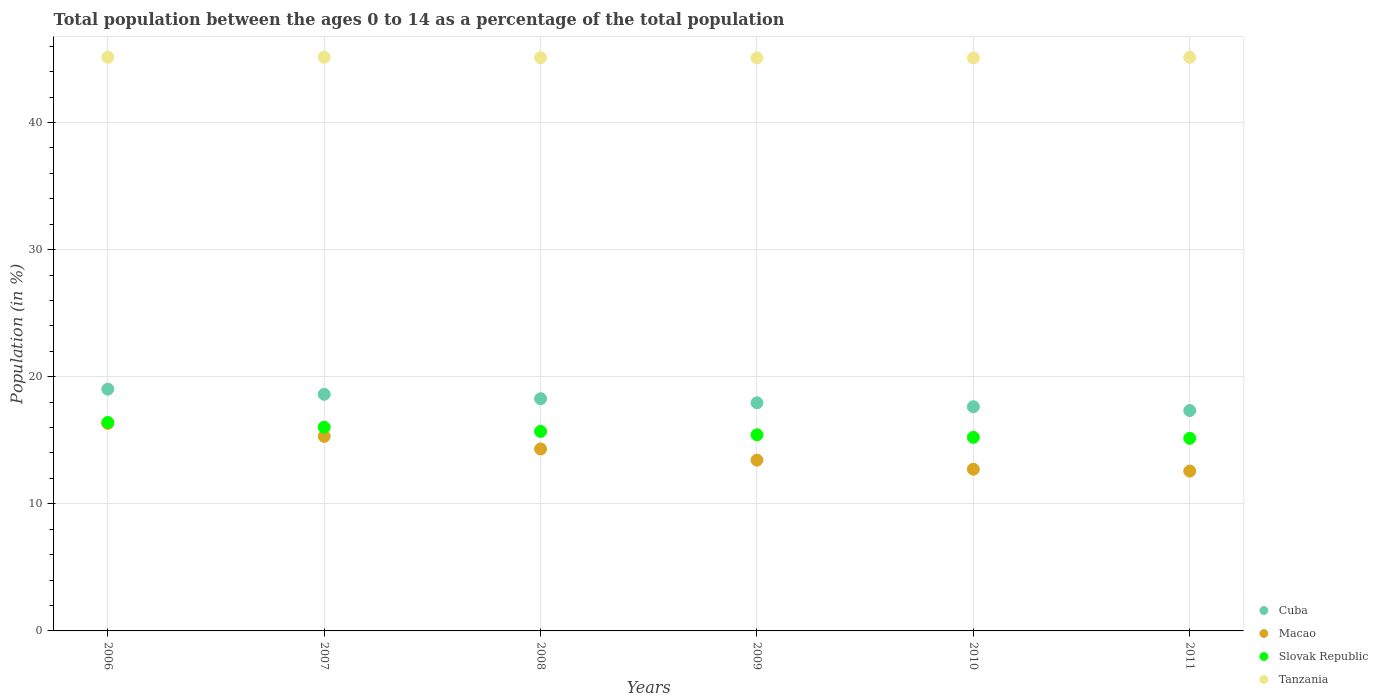How many different coloured dotlines are there?
Your answer should be very brief. 4. What is the percentage of the population ages 0 to 14 in Macao in 2007?
Your response must be concise. 15.31. Across all years, what is the maximum percentage of the population ages 0 to 14 in Macao?
Make the answer very short. 16.33. Across all years, what is the minimum percentage of the population ages 0 to 14 in Slovak Republic?
Your response must be concise. 15.15. In which year was the percentage of the population ages 0 to 14 in Macao maximum?
Your response must be concise. 2006. In which year was the percentage of the population ages 0 to 14 in Slovak Republic minimum?
Provide a short and direct response. 2011. What is the total percentage of the population ages 0 to 14 in Macao in the graph?
Provide a succinct answer. 84.68. What is the difference between the percentage of the population ages 0 to 14 in Tanzania in 2006 and that in 2009?
Provide a succinct answer. 0.05. What is the difference between the percentage of the population ages 0 to 14 in Macao in 2011 and the percentage of the population ages 0 to 14 in Tanzania in 2007?
Your answer should be very brief. -32.56. What is the average percentage of the population ages 0 to 14 in Macao per year?
Provide a short and direct response. 14.11. In the year 2008, what is the difference between the percentage of the population ages 0 to 14 in Cuba and percentage of the population ages 0 to 14 in Slovak Republic?
Offer a terse response. 2.57. What is the ratio of the percentage of the population ages 0 to 14 in Slovak Republic in 2009 to that in 2011?
Your answer should be very brief. 1.02. Is the percentage of the population ages 0 to 14 in Macao in 2006 less than that in 2010?
Your answer should be very brief. No. Is the difference between the percentage of the population ages 0 to 14 in Cuba in 2010 and 2011 greater than the difference between the percentage of the population ages 0 to 14 in Slovak Republic in 2010 and 2011?
Your answer should be compact. Yes. What is the difference between the highest and the second highest percentage of the population ages 0 to 14 in Tanzania?
Make the answer very short. 0. What is the difference between the highest and the lowest percentage of the population ages 0 to 14 in Cuba?
Provide a short and direct response. 1.68. Is the sum of the percentage of the population ages 0 to 14 in Macao in 2006 and 2008 greater than the maximum percentage of the population ages 0 to 14 in Cuba across all years?
Your answer should be very brief. Yes. Is it the case that in every year, the sum of the percentage of the population ages 0 to 14 in Cuba and percentage of the population ages 0 to 14 in Tanzania  is greater than the sum of percentage of the population ages 0 to 14 in Slovak Republic and percentage of the population ages 0 to 14 in Macao?
Provide a succinct answer. Yes. Does the percentage of the population ages 0 to 14 in Slovak Republic monotonically increase over the years?
Keep it short and to the point. No. How many years are there in the graph?
Offer a very short reply. 6. What is the difference between two consecutive major ticks on the Y-axis?
Make the answer very short. 10. Does the graph contain any zero values?
Your response must be concise. No. Does the graph contain grids?
Offer a terse response. Yes. How many legend labels are there?
Keep it short and to the point. 4. What is the title of the graph?
Give a very brief answer. Total population between the ages 0 to 14 as a percentage of the total population. What is the label or title of the Y-axis?
Your response must be concise. Population (in %). What is the Population (in %) of Cuba in 2006?
Ensure brevity in your answer.  19.02. What is the Population (in %) in Macao in 2006?
Provide a succinct answer. 16.33. What is the Population (in %) of Slovak Republic in 2006?
Make the answer very short. 16.4. What is the Population (in %) of Tanzania in 2006?
Provide a short and direct response. 45.13. What is the Population (in %) in Cuba in 2007?
Keep it short and to the point. 18.61. What is the Population (in %) in Macao in 2007?
Offer a terse response. 15.31. What is the Population (in %) of Slovak Republic in 2007?
Your answer should be very brief. 16.02. What is the Population (in %) in Tanzania in 2007?
Keep it short and to the point. 45.13. What is the Population (in %) in Cuba in 2008?
Keep it short and to the point. 18.27. What is the Population (in %) of Macao in 2008?
Your answer should be very brief. 14.32. What is the Population (in %) in Slovak Republic in 2008?
Your response must be concise. 15.7. What is the Population (in %) in Tanzania in 2008?
Give a very brief answer. 45.1. What is the Population (in %) in Cuba in 2009?
Provide a succinct answer. 17.95. What is the Population (in %) in Macao in 2009?
Your response must be concise. 13.43. What is the Population (in %) of Slovak Republic in 2009?
Give a very brief answer. 15.43. What is the Population (in %) in Tanzania in 2009?
Ensure brevity in your answer.  45.08. What is the Population (in %) in Cuba in 2010?
Provide a succinct answer. 17.64. What is the Population (in %) of Macao in 2010?
Your answer should be compact. 12.72. What is the Population (in %) in Slovak Republic in 2010?
Provide a succinct answer. 15.23. What is the Population (in %) of Tanzania in 2010?
Your answer should be compact. 45.08. What is the Population (in %) of Cuba in 2011?
Offer a very short reply. 17.34. What is the Population (in %) in Macao in 2011?
Provide a short and direct response. 12.57. What is the Population (in %) in Slovak Republic in 2011?
Offer a terse response. 15.15. What is the Population (in %) in Tanzania in 2011?
Your response must be concise. 45.12. Across all years, what is the maximum Population (in %) of Cuba?
Offer a terse response. 19.02. Across all years, what is the maximum Population (in %) of Macao?
Provide a succinct answer. 16.33. Across all years, what is the maximum Population (in %) in Slovak Republic?
Offer a terse response. 16.4. Across all years, what is the maximum Population (in %) in Tanzania?
Your response must be concise. 45.13. Across all years, what is the minimum Population (in %) of Cuba?
Make the answer very short. 17.34. Across all years, what is the minimum Population (in %) of Macao?
Your answer should be compact. 12.57. Across all years, what is the minimum Population (in %) in Slovak Republic?
Your answer should be very brief. 15.15. Across all years, what is the minimum Population (in %) in Tanzania?
Provide a short and direct response. 45.08. What is the total Population (in %) in Cuba in the graph?
Keep it short and to the point. 108.83. What is the total Population (in %) in Macao in the graph?
Ensure brevity in your answer.  84.68. What is the total Population (in %) of Slovak Republic in the graph?
Your response must be concise. 93.93. What is the total Population (in %) in Tanzania in the graph?
Your response must be concise. 270.64. What is the difference between the Population (in %) of Cuba in 2006 and that in 2007?
Your answer should be very brief. 0.41. What is the difference between the Population (in %) of Macao in 2006 and that in 2007?
Your response must be concise. 1.02. What is the difference between the Population (in %) of Slovak Republic in 2006 and that in 2007?
Your answer should be very brief. 0.37. What is the difference between the Population (in %) of Cuba in 2006 and that in 2008?
Provide a succinct answer. 0.75. What is the difference between the Population (in %) in Macao in 2006 and that in 2008?
Offer a very short reply. 2.01. What is the difference between the Population (in %) in Slovak Republic in 2006 and that in 2008?
Your answer should be compact. 0.7. What is the difference between the Population (in %) of Tanzania in 2006 and that in 2008?
Make the answer very short. 0.03. What is the difference between the Population (in %) in Cuba in 2006 and that in 2009?
Keep it short and to the point. 1.07. What is the difference between the Population (in %) in Macao in 2006 and that in 2009?
Provide a succinct answer. 2.89. What is the difference between the Population (in %) of Slovak Republic in 2006 and that in 2009?
Provide a short and direct response. 0.97. What is the difference between the Population (in %) in Tanzania in 2006 and that in 2009?
Make the answer very short. 0.05. What is the difference between the Population (in %) in Cuba in 2006 and that in 2010?
Your answer should be compact. 1.38. What is the difference between the Population (in %) in Macao in 2006 and that in 2010?
Your answer should be compact. 3.6. What is the difference between the Population (in %) in Slovak Republic in 2006 and that in 2010?
Your response must be concise. 1.17. What is the difference between the Population (in %) of Tanzania in 2006 and that in 2010?
Keep it short and to the point. 0.05. What is the difference between the Population (in %) of Cuba in 2006 and that in 2011?
Ensure brevity in your answer.  1.68. What is the difference between the Population (in %) of Macao in 2006 and that in 2011?
Your answer should be very brief. 3.75. What is the difference between the Population (in %) of Slovak Republic in 2006 and that in 2011?
Offer a very short reply. 1.25. What is the difference between the Population (in %) in Tanzania in 2006 and that in 2011?
Give a very brief answer. 0.01. What is the difference between the Population (in %) in Cuba in 2007 and that in 2008?
Make the answer very short. 0.35. What is the difference between the Population (in %) of Macao in 2007 and that in 2008?
Your response must be concise. 0.99. What is the difference between the Population (in %) in Slovak Republic in 2007 and that in 2008?
Your answer should be compact. 0.33. What is the difference between the Population (in %) in Tanzania in 2007 and that in 2008?
Provide a short and direct response. 0.03. What is the difference between the Population (in %) of Cuba in 2007 and that in 2009?
Offer a very short reply. 0.67. What is the difference between the Population (in %) in Macao in 2007 and that in 2009?
Provide a succinct answer. 1.87. What is the difference between the Population (in %) of Slovak Republic in 2007 and that in 2009?
Provide a short and direct response. 0.59. What is the difference between the Population (in %) in Tanzania in 2007 and that in 2009?
Your answer should be very brief. 0.05. What is the difference between the Population (in %) of Cuba in 2007 and that in 2010?
Your answer should be compact. 0.98. What is the difference between the Population (in %) of Macao in 2007 and that in 2010?
Provide a short and direct response. 2.58. What is the difference between the Population (in %) in Slovak Republic in 2007 and that in 2010?
Offer a terse response. 0.79. What is the difference between the Population (in %) in Tanzania in 2007 and that in 2010?
Give a very brief answer. 0.05. What is the difference between the Population (in %) of Cuba in 2007 and that in 2011?
Offer a terse response. 1.28. What is the difference between the Population (in %) of Macao in 2007 and that in 2011?
Keep it short and to the point. 2.73. What is the difference between the Population (in %) of Slovak Republic in 2007 and that in 2011?
Offer a terse response. 0.87. What is the difference between the Population (in %) in Tanzania in 2007 and that in 2011?
Ensure brevity in your answer.  0.01. What is the difference between the Population (in %) in Cuba in 2008 and that in 2009?
Provide a short and direct response. 0.32. What is the difference between the Population (in %) in Macao in 2008 and that in 2009?
Provide a succinct answer. 0.88. What is the difference between the Population (in %) in Slovak Republic in 2008 and that in 2009?
Ensure brevity in your answer.  0.27. What is the difference between the Population (in %) of Tanzania in 2008 and that in 2009?
Offer a very short reply. 0.02. What is the difference between the Population (in %) in Cuba in 2008 and that in 2010?
Your response must be concise. 0.63. What is the difference between the Population (in %) in Macao in 2008 and that in 2010?
Make the answer very short. 1.59. What is the difference between the Population (in %) of Slovak Republic in 2008 and that in 2010?
Keep it short and to the point. 0.47. What is the difference between the Population (in %) of Tanzania in 2008 and that in 2010?
Your response must be concise. 0.02. What is the difference between the Population (in %) of Cuba in 2008 and that in 2011?
Provide a short and direct response. 0.93. What is the difference between the Population (in %) in Macao in 2008 and that in 2011?
Make the answer very short. 1.74. What is the difference between the Population (in %) in Slovak Republic in 2008 and that in 2011?
Make the answer very short. 0.55. What is the difference between the Population (in %) in Tanzania in 2008 and that in 2011?
Your answer should be very brief. -0.02. What is the difference between the Population (in %) of Cuba in 2009 and that in 2010?
Offer a very short reply. 0.31. What is the difference between the Population (in %) in Macao in 2009 and that in 2010?
Give a very brief answer. 0.71. What is the difference between the Population (in %) in Slovak Republic in 2009 and that in 2010?
Your answer should be very brief. 0.2. What is the difference between the Population (in %) of Tanzania in 2009 and that in 2010?
Make the answer very short. -0. What is the difference between the Population (in %) in Cuba in 2009 and that in 2011?
Give a very brief answer. 0.61. What is the difference between the Population (in %) in Macao in 2009 and that in 2011?
Keep it short and to the point. 0.86. What is the difference between the Population (in %) in Slovak Republic in 2009 and that in 2011?
Offer a terse response. 0.28. What is the difference between the Population (in %) of Tanzania in 2009 and that in 2011?
Ensure brevity in your answer.  -0.04. What is the difference between the Population (in %) of Cuba in 2010 and that in 2011?
Your answer should be compact. 0.3. What is the difference between the Population (in %) in Macao in 2010 and that in 2011?
Offer a very short reply. 0.15. What is the difference between the Population (in %) of Slovak Republic in 2010 and that in 2011?
Your answer should be compact. 0.08. What is the difference between the Population (in %) of Tanzania in 2010 and that in 2011?
Your answer should be very brief. -0.04. What is the difference between the Population (in %) in Cuba in 2006 and the Population (in %) in Macao in 2007?
Ensure brevity in your answer.  3.71. What is the difference between the Population (in %) in Cuba in 2006 and the Population (in %) in Slovak Republic in 2007?
Give a very brief answer. 3. What is the difference between the Population (in %) of Cuba in 2006 and the Population (in %) of Tanzania in 2007?
Give a very brief answer. -26.11. What is the difference between the Population (in %) of Macao in 2006 and the Population (in %) of Slovak Republic in 2007?
Your response must be concise. 0.3. What is the difference between the Population (in %) in Macao in 2006 and the Population (in %) in Tanzania in 2007?
Your response must be concise. -28.81. What is the difference between the Population (in %) of Slovak Republic in 2006 and the Population (in %) of Tanzania in 2007?
Make the answer very short. -28.73. What is the difference between the Population (in %) of Cuba in 2006 and the Population (in %) of Macao in 2008?
Make the answer very short. 4.71. What is the difference between the Population (in %) in Cuba in 2006 and the Population (in %) in Slovak Republic in 2008?
Provide a succinct answer. 3.32. What is the difference between the Population (in %) of Cuba in 2006 and the Population (in %) of Tanzania in 2008?
Your response must be concise. -26.08. What is the difference between the Population (in %) in Macao in 2006 and the Population (in %) in Slovak Republic in 2008?
Make the answer very short. 0.63. What is the difference between the Population (in %) in Macao in 2006 and the Population (in %) in Tanzania in 2008?
Provide a short and direct response. -28.77. What is the difference between the Population (in %) of Slovak Republic in 2006 and the Population (in %) of Tanzania in 2008?
Give a very brief answer. -28.7. What is the difference between the Population (in %) of Cuba in 2006 and the Population (in %) of Macao in 2009?
Your answer should be very brief. 5.59. What is the difference between the Population (in %) in Cuba in 2006 and the Population (in %) in Slovak Republic in 2009?
Give a very brief answer. 3.59. What is the difference between the Population (in %) of Cuba in 2006 and the Population (in %) of Tanzania in 2009?
Give a very brief answer. -26.06. What is the difference between the Population (in %) in Macao in 2006 and the Population (in %) in Slovak Republic in 2009?
Provide a short and direct response. 0.89. What is the difference between the Population (in %) in Macao in 2006 and the Population (in %) in Tanzania in 2009?
Provide a short and direct response. -28.75. What is the difference between the Population (in %) of Slovak Republic in 2006 and the Population (in %) of Tanzania in 2009?
Give a very brief answer. -28.68. What is the difference between the Population (in %) of Cuba in 2006 and the Population (in %) of Macao in 2010?
Keep it short and to the point. 6.3. What is the difference between the Population (in %) in Cuba in 2006 and the Population (in %) in Slovak Republic in 2010?
Your answer should be compact. 3.79. What is the difference between the Population (in %) of Cuba in 2006 and the Population (in %) of Tanzania in 2010?
Give a very brief answer. -26.06. What is the difference between the Population (in %) of Macao in 2006 and the Population (in %) of Slovak Republic in 2010?
Your answer should be very brief. 1.09. What is the difference between the Population (in %) of Macao in 2006 and the Population (in %) of Tanzania in 2010?
Offer a terse response. -28.76. What is the difference between the Population (in %) of Slovak Republic in 2006 and the Population (in %) of Tanzania in 2010?
Provide a short and direct response. -28.68. What is the difference between the Population (in %) in Cuba in 2006 and the Population (in %) in Macao in 2011?
Your answer should be very brief. 6.45. What is the difference between the Population (in %) in Cuba in 2006 and the Population (in %) in Slovak Republic in 2011?
Your answer should be very brief. 3.87. What is the difference between the Population (in %) in Cuba in 2006 and the Population (in %) in Tanzania in 2011?
Ensure brevity in your answer.  -26.1. What is the difference between the Population (in %) of Macao in 2006 and the Population (in %) of Slovak Republic in 2011?
Your answer should be very brief. 1.17. What is the difference between the Population (in %) in Macao in 2006 and the Population (in %) in Tanzania in 2011?
Give a very brief answer. -28.79. What is the difference between the Population (in %) of Slovak Republic in 2006 and the Population (in %) of Tanzania in 2011?
Keep it short and to the point. -28.72. What is the difference between the Population (in %) in Cuba in 2007 and the Population (in %) in Macao in 2008?
Your answer should be compact. 4.3. What is the difference between the Population (in %) of Cuba in 2007 and the Population (in %) of Slovak Republic in 2008?
Offer a very short reply. 2.92. What is the difference between the Population (in %) of Cuba in 2007 and the Population (in %) of Tanzania in 2008?
Offer a very short reply. -26.48. What is the difference between the Population (in %) in Macao in 2007 and the Population (in %) in Slovak Republic in 2008?
Make the answer very short. -0.39. What is the difference between the Population (in %) of Macao in 2007 and the Population (in %) of Tanzania in 2008?
Ensure brevity in your answer.  -29.79. What is the difference between the Population (in %) in Slovak Republic in 2007 and the Population (in %) in Tanzania in 2008?
Give a very brief answer. -29.07. What is the difference between the Population (in %) of Cuba in 2007 and the Population (in %) of Macao in 2009?
Provide a succinct answer. 5.18. What is the difference between the Population (in %) of Cuba in 2007 and the Population (in %) of Slovak Republic in 2009?
Your response must be concise. 3.18. What is the difference between the Population (in %) of Cuba in 2007 and the Population (in %) of Tanzania in 2009?
Make the answer very short. -26.46. What is the difference between the Population (in %) in Macao in 2007 and the Population (in %) in Slovak Republic in 2009?
Ensure brevity in your answer.  -0.13. What is the difference between the Population (in %) in Macao in 2007 and the Population (in %) in Tanzania in 2009?
Ensure brevity in your answer.  -29.77. What is the difference between the Population (in %) in Slovak Republic in 2007 and the Population (in %) in Tanzania in 2009?
Your response must be concise. -29.05. What is the difference between the Population (in %) of Cuba in 2007 and the Population (in %) of Macao in 2010?
Offer a terse response. 5.89. What is the difference between the Population (in %) of Cuba in 2007 and the Population (in %) of Slovak Republic in 2010?
Your response must be concise. 3.38. What is the difference between the Population (in %) in Cuba in 2007 and the Population (in %) in Tanzania in 2010?
Provide a short and direct response. -26.47. What is the difference between the Population (in %) of Macao in 2007 and the Population (in %) of Slovak Republic in 2010?
Keep it short and to the point. 0.08. What is the difference between the Population (in %) of Macao in 2007 and the Population (in %) of Tanzania in 2010?
Your answer should be compact. -29.77. What is the difference between the Population (in %) of Slovak Republic in 2007 and the Population (in %) of Tanzania in 2010?
Give a very brief answer. -29.06. What is the difference between the Population (in %) in Cuba in 2007 and the Population (in %) in Macao in 2011?
Your answer should be very brief. 6.04. What is the difference between the Population (in %) in Cuba in 2007 and the Population (in %) in Slovak Republic in 2011?
Make the answer very short. 3.46. What is the difference between the Population (in %) in Cuba in 2007 and the Population (in %) in Tanzania in 2011?
Offer a terse response. -26.5. What is the difference between the Population (in %) in Macao in 2007 and the Population (in %) in Slovak Republic in 2011?
Make the answer very short. 0.15. What is the difference between the Population (in %) of Macao in 2007 and the Population (in %) of Tanzania in 2011?
Keep it short and to the point. -29.81. What is the difference between the Population (in %) in Slovak Republic in 2007 and the Population (in %) in Tanzania in 2011?
Your response must be concise. -29.09. What is the difference between the Population (in %) in Cuba in 2008 and the Population (in %) in Macao in 2009?
Provide a short and direct response. 4.84. What is the difference between the Population (in %) of Cuba in 2008 and the Population (in %) of Slovak Republic in 2009?
Provide a succinct answer. 2.84. What is the difference between the Population (in %) of Cuba in 2008 and the Population (in %) of Tanzania in 2009?
Offer a terse response. -26.81. What is the difference between the Population (in %) of Macao in 2008 and the Population (in %) of Slovak Republic in 2009?
Your response must be concise. -1.12. What is the difference between the Population (in %) in Macao in 2008 and the Population (in %) in Tanzania in 2009?
Your answer should be very brief. -30.76. What is the difference between the Population (in %) of Slovak Republic in 2008 and the Population (in %) of Tanzania in 2009?
Ensure brevity in your answer.  -29.38. What is the difference between the Population (in %) in Cuba in 2008 and the Population (in %) in Macao in 2010?
Ensure brevity in your answer.  5.55. What is the difference between the Population (in %) in Cuba in 2008 and the Population (in %) in Slovak Republic in 2010?
Offer a terse response. 3.04. What is the difference between the Population (in %) in Cuba in 2008 and the Population (in %) in Tanzania in 2010?
Your answer should be very brief. -26.81. What is the difference between the Population (in %) of Macao in 2008 and the Population (in %) of Slovak Republic in 2010?
Your answer should be very brief. -0.92. What is the difference between the Population (in %) of Macao in 2008 and the Population (in %) of Tanzania in 2010?
Give a very brief answer. -30.76. What is the difference between the Population (in %) of Slovak Republic in 2008 and the Population (in %) of Tanzania in 2010?
Ensure brevity in your answer.  -29.38. What is the difference between the Population (in %) in Cuba in 2008 and the Population (in %) in Macao in 2011?
Your response must be concise. 5.69. What is the difference between the Population (in %) of Cuba in 2008 and the Population (in %) of Slovak Republic in 2011?
Offer a terse response. 3.12. What is the difference between the Population (in %) of Cuba in 2008 and the Population (in %) of Tanzania in 2011?
Your answer should be very brief. -26.85. What is the difference between the Population (in %) of Macao in 2008 and the Population (in %) of Slovak Republic in 2011?
Offer a terse response. -0.84. What is the difference between the Population (in %) in Macao in 2008 and the Population (in %) in Tanzania in 2011?
Provide a succinct answer. -30.8. What is the difference between the Population (in %) in Slovak Republic in 2008 and the Population (in %) in Tanzania in 2011?
Your response must be concise. -29.42. What is the difference between the Population (in %) in Cuba in 2009 and the Population (in %) in Macao in 2010?
Your answer should be compact. 5.23. What is the difference between the Population (in %) of Cuba in 2009 and the Population (in %) of Slovak Republic in 2010?
Ensure brevity in your answer.  2.72. What is the difference between the Population (in %) of Cuba in 2009 and the Population (in %) of Tanzania in 2010?
Provide a short and direct response. -27.13. What is the difference between the Population (in %) of Macao in 2009 and the Population (in %) of Slovak Republic in 2010?
Offer a very short reply. -1.8. What is the difference between the Population (in %) of Macao in 2009 and the Population (in %) of Tanzania in 2010?
Your answer should be very brief. -31.65. What is the difference between the Population (in %) in Slovak Republic in 2009 and the Population (in %) in Tanzania in 2010?
Provide a short and direct response. -29.65. What is the difference between the Population (in %) in Cuba in 2009 and the Population (in %) in Macao in 2011?
Offer a terse response. 5.37. What is the difference between the Population (in %) of Cuba in 2009 and the Population (in %) of Slovak Republic in 2011?
Keep it short and to the point. 2.8. What is the difference between the Population (in %) of Cuba in 2009 and the Population (in %) of Tanzania in 2011?
Your answer should be very brief. -27.17. What is the difference between the Population (in %) of Macao in 2009 and the Population (in %) of Slovak Republic in 2011?
Your response must be concise. -1.72. What is the difference between the Population (in %) of Macao in 2009 and the Population (in %) of Tanzania in 2011?
Provide a short and direct response. -31.69. What is the difference between the Population (in %) of Slovak Republic in 2009 and the Population (in %) of Tanzania in 2011?
Offer a terse response. -29.69. What is the difference between the Population (in %) in Cuba in 2010 and the Population (in %) in Macao in 2011?
Your answer should be very brief. 5.06. What is the difference between the Population (in %) of Cuba in 2010 and the Population (in %) of Slovak Republic in 2011?
Ensure brevity in your answer.  2.49. What is the difference between the Population (in %) in Cuba in 2010 and the Population (in %) in Tanzania in 2011?
Your answer should be very brief. -27.48. What is the difference between the Population (in %) in Macao in 2010 and the Population (in %) in Slovak Republic in 2011?
Provide a short and direct response. -2.43. What is the difference between the Population (in %) in Macao in 2010 and the Population (in %) in Tanzania in 2011?
Make the answer very short. -32.4. What is the difference between the Population (in %) of Slovak Republic in 2010 and the Population (in %) of Tanzania in 2011?
Your answer should be very brief. -29.89. What is the average Population (in %) in Cuba per year?
Give a very brief answer. 18.14. What is the average Population (in %) in Macao per year?
Your answer should be very brief. 14.11. What is the average Population (in %) in Slovak Republic per year?
Your answer should be compact. 15.66. What is the average Population (in %) of Tanzania per year?
Make the answer very short. 45.11. In the year 2006, what is the difference between the Population (in %) of Cuba and Population (in %) of Macao?
Ensure brevity in your answer.  2.7. In the year 2006, what is the difference between the Population (in %) of Cuba and Population (in %) of Slovak Republic?
Keep it short and to the point. 2.62. In the year 2006, what is the difference between the Population (in %) of Cuba and Population (in %) of Tanzania?
Ensure brevity in your answer.  -26.11. In the year 2006, what is the difference between the Population (in %) in Macao and Population (in %) in Slovak Republic?
Ensure brevity in your answer.  -0.07. In the year 2006, what is the difference between the Population (in %) in Macao and Population (in %) in Tanzania?
Offer a terse response. -28.81. In the year 2006, what is the difference between the Population (in %) of Slovak Republic and Population (in %) of Tanzania?
Provide a succinct answer. -28.73. In the year 2007, what is the difference between the Population (in %) of Cuba and Population (in %) of Macao?
Your answer should be very brief. 3.31. In the year 2007, what is the difference between the Population (in %) of Cuba and Population (in %) of Slovak Republic?
Your answer should be very brief. 2.59. In the year 2007, what is the difference between the Population (in %) of Cuba and Population (in %) of Tanzania?
Offer a terse response. -26.52. In the year 2007, what is the difference between the Population (in %) of Macao and Population (in %) of Slovak Republic?
Your response must be concise. -0.72. In the year 2007, what is the difference between the Population (in %) in Macao and Population (in %) in Tanzania?
Your answer should be very brief. -29.82. In the year 2007, what is the difference between the Population (in %) of Slovak Republic and Population (in %) of Tanzania?
Keep it short and to the point. -29.11. In the year 2008, what is the difference between the Population (in %) in Cuba and Population (in %) in Macao?
Ensure brevity in your answer.  3.95. In the year 2008, what is the difference between the Population (in %) of Cuba and Population (in %) of Slovak Republic?
Your response must be concise. 2.57. In the year 2008, what is the difference between the Population (in %) in Cuba and Population (in %) in Tanzania?
Make the answer very short. -26.83. In the year 2008, what is the difference between the Population (in %) in Macao and Population (in %) in Slovak Republic?
Your answer should be compact. -1.38. In the year 2008, what is the difference between the Population (in %) of Macao and Population (in %) of Tanzania?
Give a very brief answer. -30.78. In the year 2008, what is the difference between the Population (in %) of Slovak Republic and Population (in %) of Tanzania?
Provide a short and direct response. -29.4. In the year 2009, what is the difference between the Population (in %) of Cuba and Population (in %) of Macao?
Provide a short and direct response. 4.51. In the year 2009, what is the difference between the Population (in %) in Cuba and Population (in %) in Slovak Republic?
Your answer should be very brief. 2.52. In the year 2009, what is the difference between the Population (in %) of Cuba and Population (in %) of Tanzania?
Your answer should be very brief. -27.13. In the year 2009, what is the difference between the Population (in %) in Macao and Population (in %) in Slovak Republic?
Offer a very short reply. -2. In the year 2009, what is the difference between the Population (in %) of Macao and Population (in %) of Tanzania?
Offer a terse response. -31.64. In the year 2009, what is the difference between the Population (in %) of Slovak Republic and Population (in %) of Tanzania?
Your answer should be very brief. -29.64. In the year 2010, what is the difference between the Population (in %) in Cuba and Population (in %) in Macao?
Provide a short and direct response. 4.92. In the year 2010, what is the difference between the Population (in %) in Cuba and Population (in %) in Slovak Republic?
Your answer should be very brief. 2.41. In the year 2010, what is the difference between the Population (in %) of Cuba and Population (in %) of Tanzania?
Provide a succinct answer. -27.44. In the year 2010, what is the difference between the Population (in %) in Macao and Population (in %) in Slovak Republic?
Provide a succinct answer. -2.51. In the year 2010, what is the difference between the Population (in %) in Macao and Population (in %) in Tanzania?
Your response must be concise. -32.36. In the year 2010, what is the difference between the Population (in %) of Slovak Republic and Population (in %) of Tanzania?
Keep it short and to the point. -29.85. In the year 2011, what is the difference between the Population (in %) in Cuba and Population (in %) in Macao?
Offer a very short reply. 4.76. In the year 2011, what is the difference between the Population (in %) of Cuba and Population (in %) of Slovak Republic?
Your answer should be very brief. 2.19. In the year 2011, what is the difference between the Population (in %) in Cuba and Population (in %) in Tanzania?
Offer a very short reply. -27.78. In the year 2011, what is the difference between the Population (in %) in Macao and Population (in %) in Slovak Republic?
Provide a succinct answer. -2.58. In the year 2011, what is the difference between the Population (in %) in Macao and Population (in %) in Tanzania?
Your answer should be compact. -32.54. In the year 2011, what is the difference between the Population (in %) in Slovak Republic and Population (in %) in Tanzania?
Your answer should be very brief. -29.97. What is the ratio of the Population (in %) of Cuba in 2006 to that in 2007?
Your response must be concise. 1.02. What is the ratio of the Population (in %) in Macao in 2006 to that in 2007?
Ensure brevity in your answer.  1.07. What is the ratio of the Population (in %) in Slovak Republic in 2006 to that in 2007?
Offer a very short reply. 1.02. What is the ratio of the Population (in %) in Cuba in 2006 to that in 2008?
Provide a short and direct response. 1.04. What is the ratio of the Population (in %) of Macao in 2006 to that in 2008?
Make the answer very short. 1.14. What is the ratio of the Population (in %) in Slovak Republic in 2006 to that in 2008?
Keep it short and to the point. 1.04. What is the ratio of the Population (in %) in Tanzania in 2006 to that in 2008?
Ensure brevity in your answer.  1. What is the ratio of the Population (in %) of Cuba in 2006 to that in 2009?
Offer a terse response. 1.06. What is the ratio of the Population (in %) of Macao in 2006 to that in 2009?
Make the answer very short. 1.22. What is the ratio of the Population (in %) of Slovak Republic in 2006 to that in 2009?
Your answer should be compact. 1.06. What is the ratio of the Population (in %) in Tanzania in 2006 to that in 2009?
Give a very brief answer. 1. What is the ratio of the Population (in %) of Cuba in 2006 to that in 2010?
Your answer should be very brief. 1.08. What is the ratio of the Population (in %) of Macao in 2006 to that in 2010?
Your answer should be compact. 1.28. What is the ratio of the Population (in %) of Slovak Republic in 2006 to that in 2010?
Offer a terse response. 1.08. What is the ratio of the Population (in %) of Cuba in 2006 to that in 2011?
Offer a very short reply. 1.1. What is the ratio of the Population (in %) of Macao in 2006 to that in 2011?
Make the answer very short. 1.3. What is the ratio of the Population (in %) in Slovak Republic in 2006 to that in 2011?
Give a very brief answer. 1.08. What is the ratio of the Population (in %) in Tanzania in 2006 to that in 2011?
Ensure brevity in your answer.  1. What is the ratio of the Population (in %) in Macao in 2007 to that in 2008?
Make the answer very short. 1.07. What is the ratio of the Population (in %) of Slovak Republic in 2007 to that in 2008?
Offer a very short reply. 1.02. What is the ratio of the Population (in %) in Tanzania in 2007 to that in 2008?
Provide a succinct answer. 1. What is the ratio of the Population (in %) of Cuba in 2007 to that in 2009?
Provide a succinct answer. 1.04. What is the ratio of the Population (in %) of Macao in 2007 to that in 2009?
Offer a very short reply. 1.14. What is the ratio of the Population (in %) in Slovak Republic in 2007 to that in 2009?
Provide a succinct answer. 1.04. What is the ratio of the Population (in %) in Cuba in 2007 to that in 2010?
Ensure brevity in your answer.  1.06. What is the ratio of the Population (in %) in Macao in 2007 to that in 2010?
Make the answer very short. 1.2. What is the ratio of the Population (in %) in Slovak Republic in 2007 to that in 2010?
Your answer should be very brief. 1.05. What is the ratio of the Population (in %) in Cuba in 2007 to that in 2011?
Keep it short and to the point. 1.07. What is the ratio of the Population (in %) in Macao in 2007 to that in 2011?
Make the answer very short. 1.22. What is the ratio of the Population (in %) in Slovak Republic in 2007 to that in 2011?
Provide a short and direct response. 1.06. What is the ratio of the Population (in %) of Tanzania in 2007 to that in 2011?
Your answer should be compact. 1. What is the ratio of the Population (in %) in Cuba in 2008 to that in 2009?
Make the answer very short. 1.02. What is the ratio of the Population (in %) of Macao in 2008 to that in 2009?
Provide a succinct answer. 1.07. What is the ratio of the Population (in %) in Slovak Republic in 2008 to that in 2009?
Give a very brief answer. 1.02. What is the ratio of the Population (in %) in Tanzania in 2008 to that in 2009?
Ensure brevity in your answer.  1. What is the ratio of the Population (in %) of Cuba in 2008 to that in 2010?
Give a very brief answer. 1.04. What is the ratio of the Population (in %) in Macao in 2008 to that in 2010?
Offer a very short reply. 1.13. What is the ratio of the Population (in %) in Slovak Republic in 2008 to that in 2010?
Your answer should be very brief. 1.03. What is the ratio of the Population (in %) of Cuba in 2008 to that in 2011?
Keep it short and to the point. 1.05. What is the ratio of the Population (in %) of Macao in 2008 to that in 2011?
Provide a short and direct response. 1.14. What is the ratio of the Population (in %) in Slovak Republic in 2008 to that in 2011?
Make the answer very short. 1.04. What is the ratio of the Population (in %) in Tanzania in 2008 to that in 2011?
Ensure brevity in your answer.  1. What is the ratio of the Population (in %) in Cuba in 2009 to that in 2010?
Keep it short and to the point. 1.02. What is the ratio of the Population (in %) in Macao in 2009 to that in 2010?
Ensure brevity in your answer.  1.06. What is the ratio of the Population (in %) of Slovak Republic in 2009 to that in 2010?
Offer a very short reply. 1.01. What is the ratio of the Population (in %) in Cuba in 2009 to that in 2011?
Keep it short and to the point. 1.04. What is the ratio of the Population (in %) of Macao in 2009 to that in 2011?
Provide a short and direct response. 1.07. What is the ratio of the Population (in %) of Slovak Republic in 2009 to that in 2011?
Ensure brevity in your answer.  1.02. What is the ratio of the Population (in %) of Cuba in 2010 to that in 2011?
Offer a very short reply. 1.02. What is the ratio of the Population (in %) in Macao in 2010 to that in 2011?
Your response must be concise. 1.01. What is the difference between the highest and the second highest Population (in %) of Cuba?
Your answer should be compact. 0.41. What is the difference between the highest and the second highest Population (in %) in Macao?
Give a very brief answer. 1.02. What is the difference between the highest and the second highest Population (in %) of Slovak Republic?
Ensure brevity in your answer.  0.37. What is the difference between the highest and the lowest Population (in %) of Cuba?
Give a very brief answer. 1.68. What is the difference between the highest and the lowest Population (in %) of Macao?
Give a very brief answer. 3.75. What is the difference between the highest and the lowest Population (in %) in Slovak Republic?
Provide a succinct answer. 1.25. What is the difference between the highest and the lowest Population (in %) of Tanzania?
Provide a succinct answer. 0.05. 